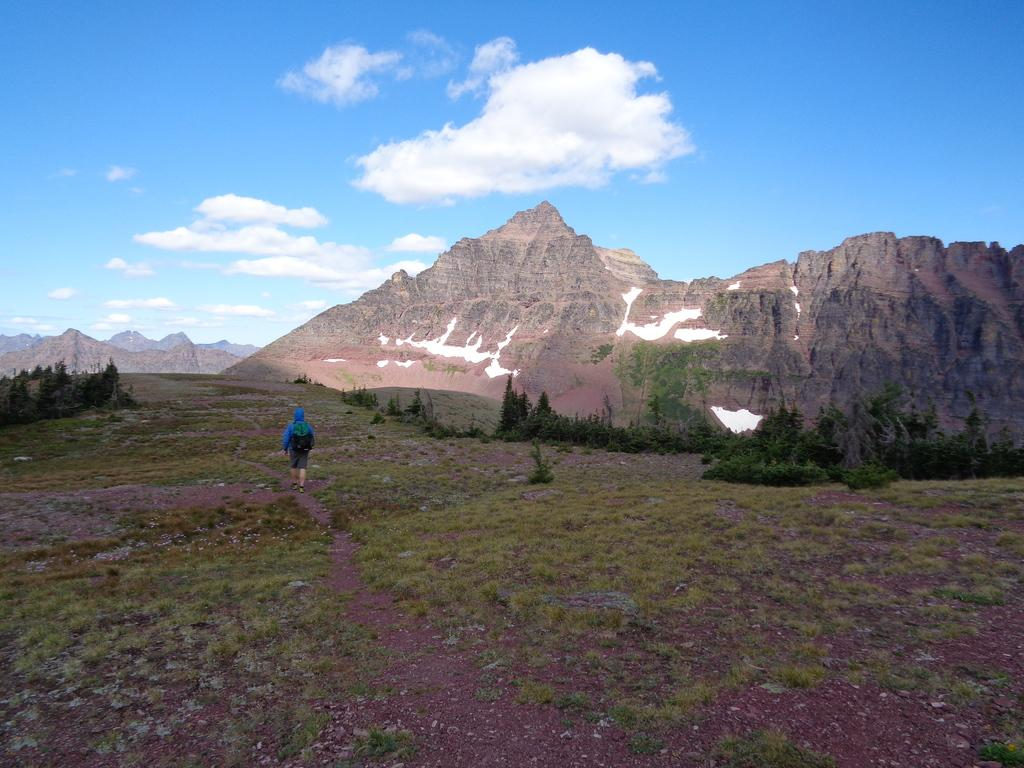What is the main subject in the image? There is a person standing in the image. What natural features can be seen in the background? Mountains are visible in the image. What type of vegetation is present in the image? Trees and plants are present in the image. What is the ground covered with in the image? Grass is visible in the image. What can be seen in the sky in the image? Clouds are present in the sky in the image. What type of gold can be seen on the person's leg in the image? There is no gold visible on the person's leg in the image. What is the friction between the person and the ground in the image? The friction between the person and the ground cannot be determined from the image. 